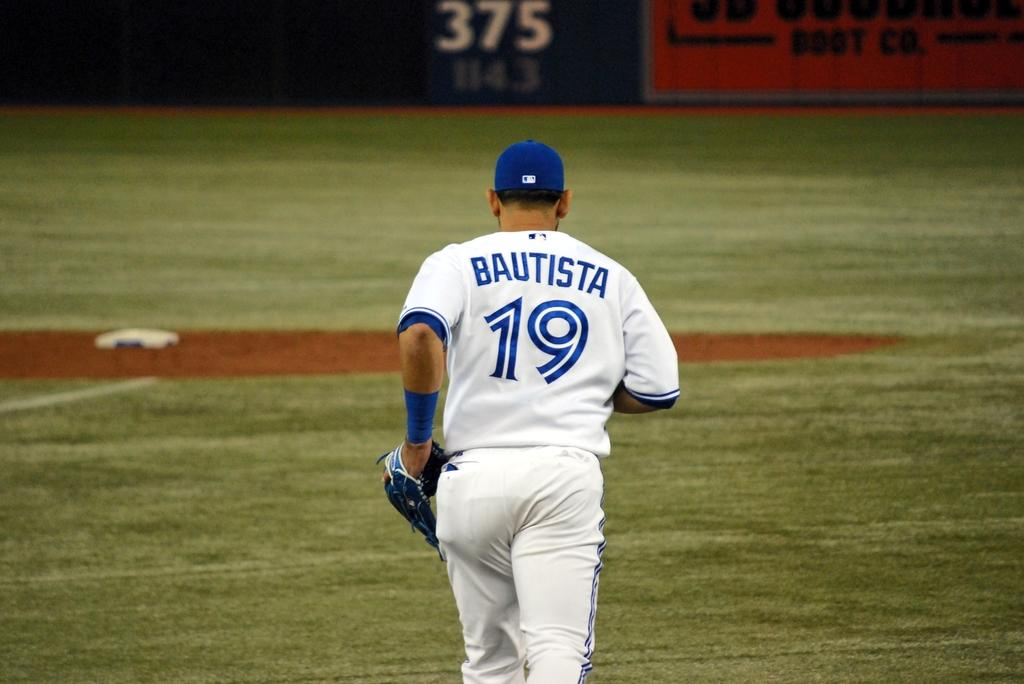<image>
Provide a brief description of the given image. A baseball player is jogging on the field and his shirt says Bautista 19. 